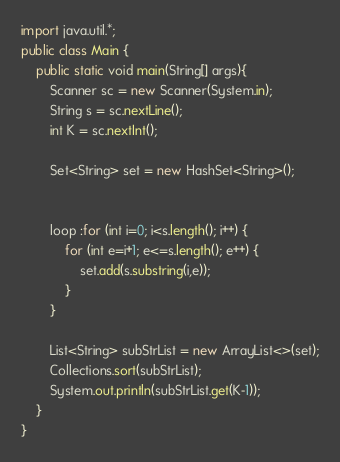Convert code to text. <code><loc_0><loc_0><loc_500><loc_500><_Java_>import java.util.*;
public class Main {
	public static void main(String[] args){
		Scanner sc = new Scanner(System.in);
		String s = sc.nextLine();
		int K = sc.nextInt();

		Set<String> set = new HashSet<String>();


		loop :for (int i=0; i<s.length(); i++) {
			for (int e=i+1; e<=s.length(); e++) {
				set.add(s.substring(i,e));
			}
		}

		List<String> subStrList = new ArrayList<>(set);
		Collections.sort(subStrList);
		System.out.println(subStrList.get(K-1));
	}
}

</code> 